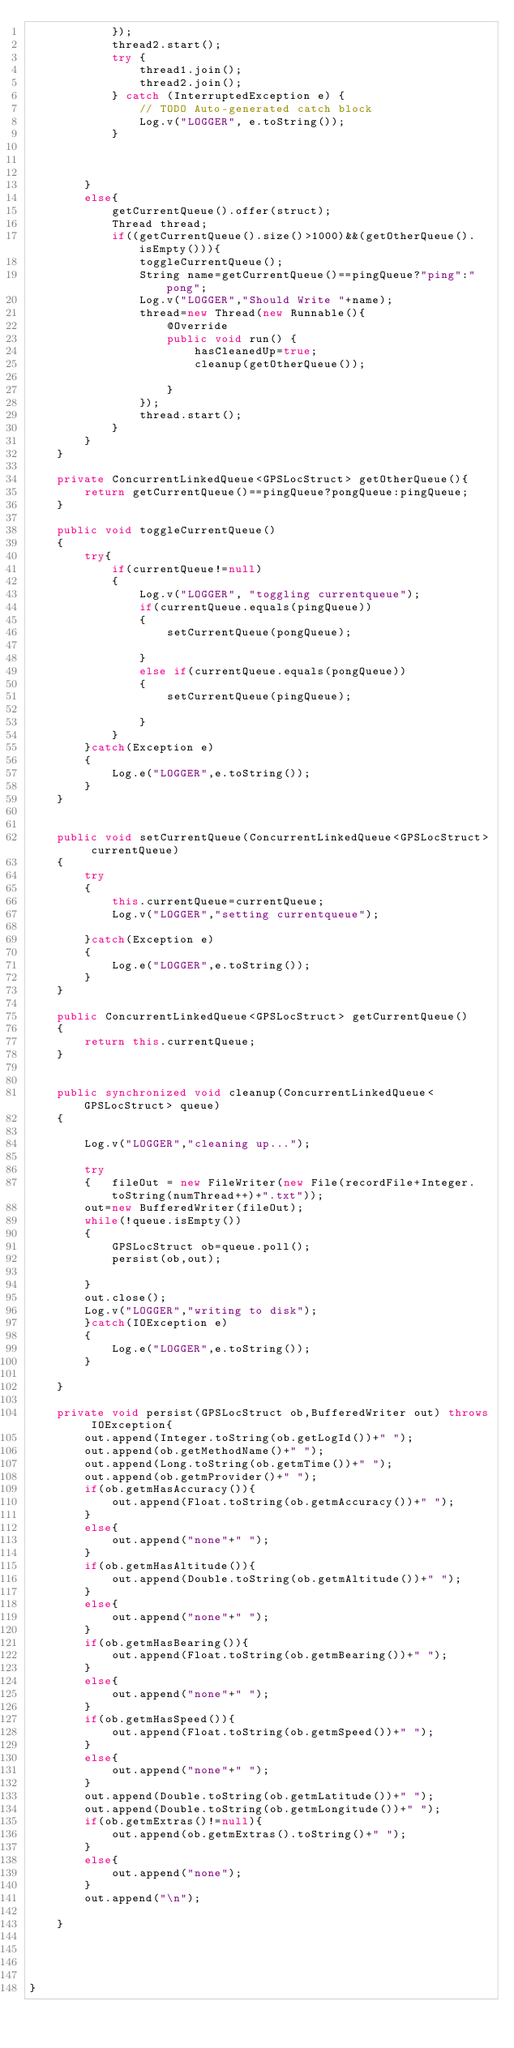Convert code to text. <code><loc_0><loc_0><loc_500><loc_500><_Java_>			});
			thread2.start();
			try {
				thread1.join();
				thread2.join();
			} catch (InterruptedException e) {
				// TODO Auto-generated catch block
				Log.v("LOGGER", e.toString());
			} 



		}
		else{
			getCurrentQueue().offer(struct);
			Thread thread;
			if((getCurrentQueue().size()>1000)&&(getOtherQueue().isEmpty())){
				toggleCurrentQueue();
				String name=getCurrentQueue()==pingQueue?"ping":"pong";
				Log.v("LOGGER","Should Write "+name);
				thread=new Thread(new Runnable(){
					@Override
					public void run() {
						hasCleanedUp=true;
						cleanup(getOtherQueue());

					}
				});
				thread.start();
			}
		}
	}

	private ConcurrentLinkedQueue<GPSLocStruct> getOtherQueue(){
		return getCurrentQueue()==pingQueue?pongQueue:pingQueue;
	}

	public void toggleCurrentQueue() 
	{
		try{
			if(currentQueue!=null)
			{
				Log.v("LOGGER", "toggling currentqueue");
				if(currentQueue.equals(pingQueue))
				{
					setCurrentQueue(pongQueue);

				}
				else if(currentQueue.equals(pongQueue))
				{
					setCurrentQueue(pingQueue);

				}
			}
		}catch(Exception e)
		{
			Log.e("LOGGER",e.toString());
		}
	}


	public void setCurrentQueue(ConcurrentLinkedQueue<GPSLocStruct> currentQueue)
	{
		try
		{
			this.currentQueue=currentQueue;
			Log.v("LOGGER","setting currentqueue");

		}catch(Exception e)
		{
			Log.e("LOGGER",e.toString());
		}
	}

	public ConcurrentLinkedQueue<GPSLocStruct> getCurrentQueue()
	{
		return this.currentQueue;
	}


	public synchronized void cleanup(ConcurrentLinkedQueue<GPSLocStruct> queue)
	{

		Log.v("LOGGER","cleaning up...");

		try
		{ 	fileOut = new FileWriter(new File(recordFile+Integer.toString(numThread++)+".txt"));
		out=new BufferedWriter(fileOut);
		while(!queue.isEmpty())
		{
			GPSLocStruct ob=queue.poll();
			persist(ob,out);

		}
		out.close();
		Log.v("LOGGER","writing to disk");
		}catch(IOException e)
		{
			Log.e("LOGGER",e.toString());
		}

	}

	private void persist(GPSLocStruct ob,BufferedWriter out) throws IOException{
		out.append(Integer.toString(ob.getLogId())+" ");
		out.append(ob.getMethodName()+" ");
		out.append(Long.toString(ob.getmTime())+" ");
		out.append(ob.getmProvider()+" ");
		if(ob.getmHasAccuracy()){
			out.append(Float.toString(ob.getmAccuracy())+" ");
		}
		else{
			out.append("none"+" ");
		}
		if(ob.getmHasAltitude()){
			out.append(Double.toString(ob.getmAltitude())+" ");
		}
		else{
			out.append("none"+" ");
		}
		if(ob.getmHasBearing()){
			out.append(Float.toString(ob.getmBearing())+" ");
		}
		else{
			out.append("none"+" ");
		}
		if(ob.getmHasSpeed()){
			out.append(Float.toString(ob.getmSpeed())+" ");
		}
		else{
			out.append("none"+" ");
		}
		out.append(Double.toString(ob.getmLatitude())+" ");
		out.append(Double.toString(ob.getmLongitude())+" ");
		if(ob.getmExtras()!=null){
			out.append(ob.getmExtras().toString()+" ");
		}
		else{
			out.append("none");
		}
		out.append("\n");
		
	}




}
</code> 